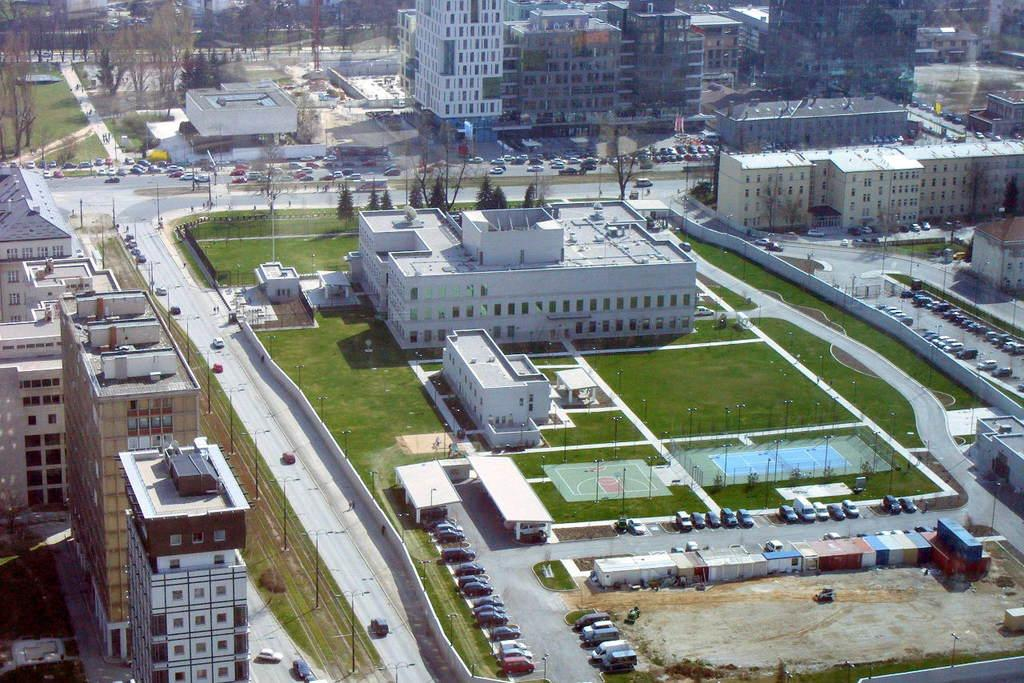What is happening on the road in the image? There are vehicles on the road in the image. What can be seen in the distance behind the vehicles? There are buildings and trees in the background of the image. Is there a fingerprint visible on the windshield of any vehicle in the image? There is no mention of a fingerprint or any specific details about the vehicles' windshields in the image. 